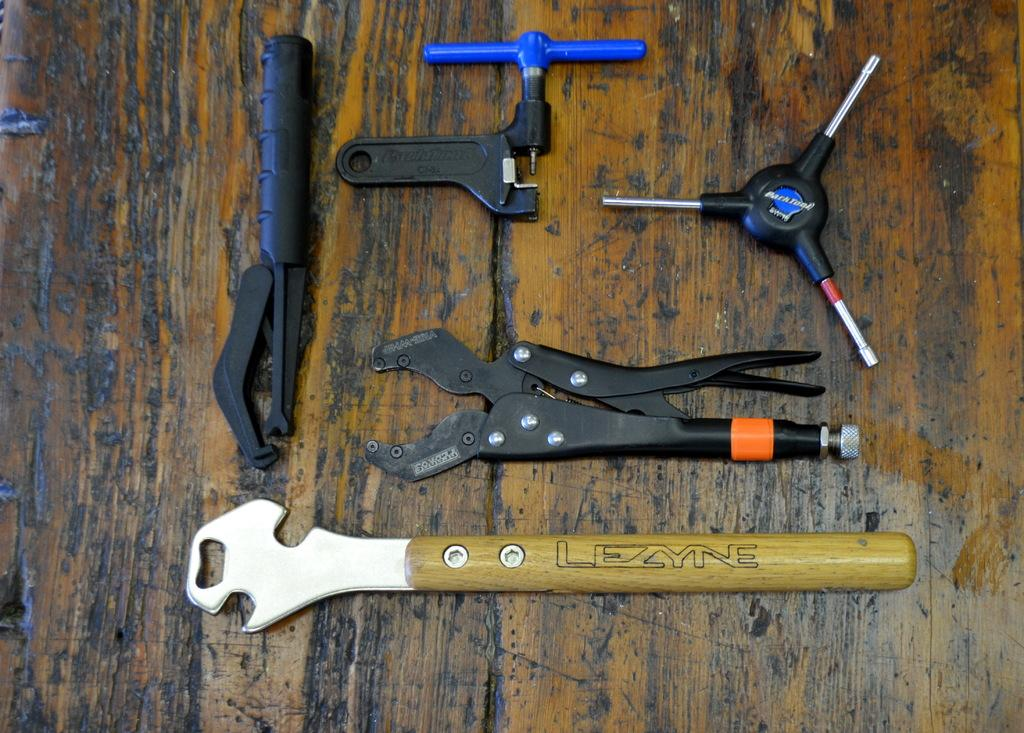What objects can be seen in the image? There are tools in the image. Where are the tools located? The tools are on a wooden table. What time of day is it according to the calendar in the image? There is no calendar present in the image, so it is not possible to determine the time of day from the image. 